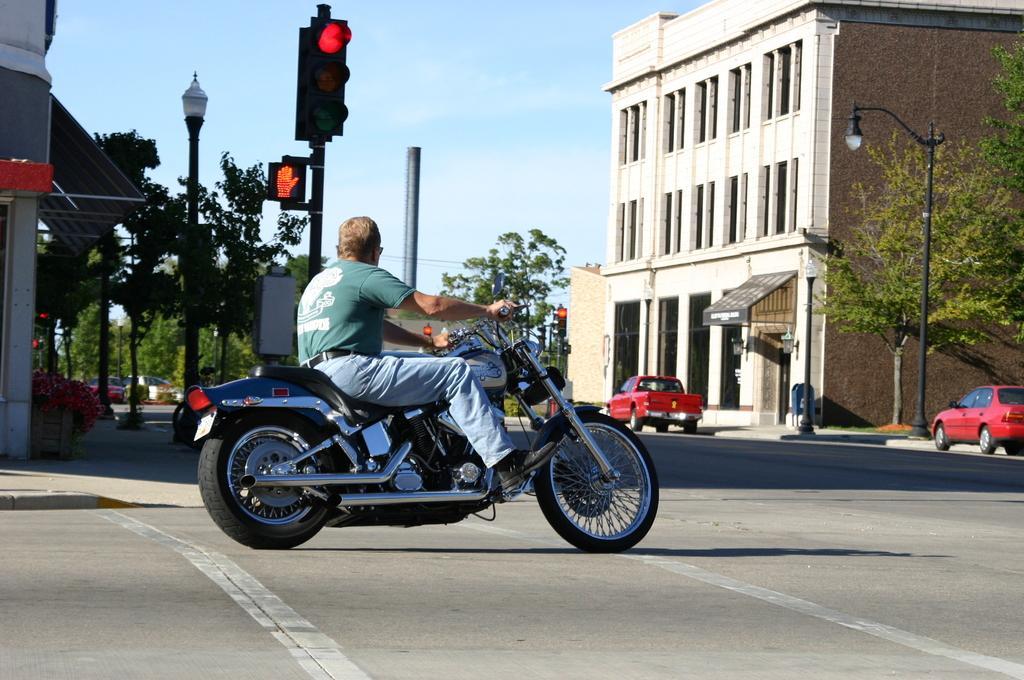Please provide a concise description of this image. This picture shows a man riding a motorcycle and we see couple of buildings and trees around and two cars parked on the road 